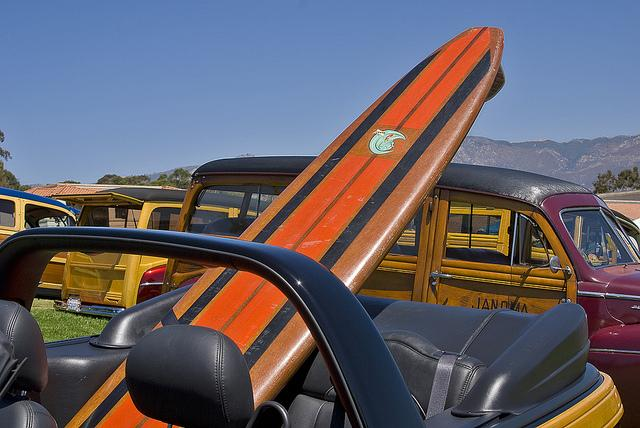Who played the character on the Brady Bunch whose name can be spelled with the first three letters shown on the vehicle? Please explain your reasoning. eve plumb. The first three letters on the vehicle match the character. 